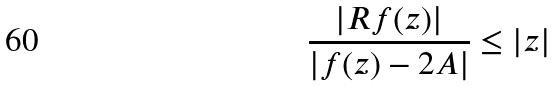Convert formula to latex. <formula><loc_0><loc_0><loc_500><loc_500>\frac { | R f ( z ) | } { | f ( z ) - 2 A | } \leq | z |</formula> 